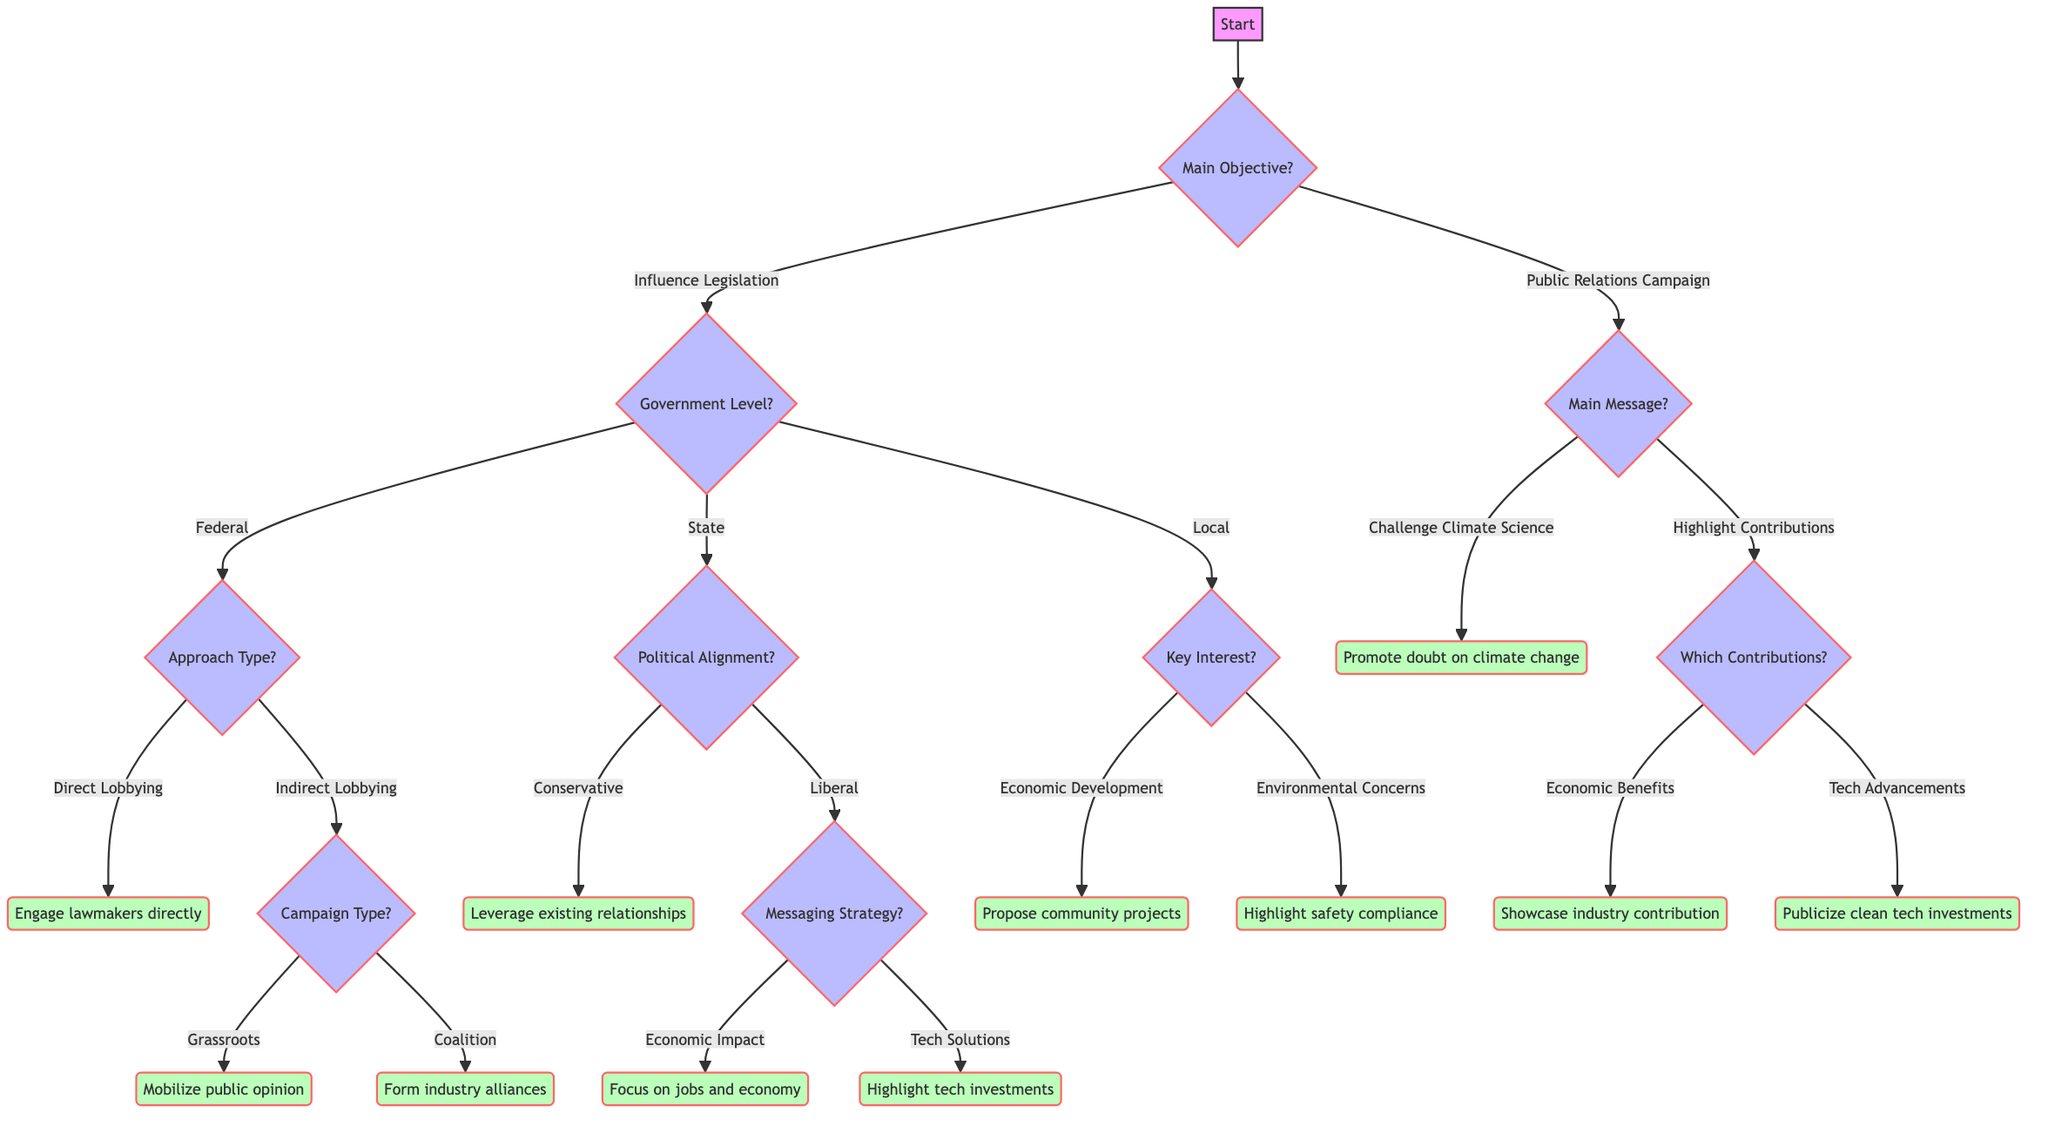What is the main objective of the lobbying effort? The diagram's first node asks about the main objective of the lobbying effort; the options are "Influence Legislation" and "Public Relations Campaign". Since it's a direct inquiry, we can answer by simply choosing one of these options.
Answer: Influence Legislation How many approaches are available under Federal lobbying? From the diagram, if we follow the path starting from "Influence Legislation" and then to "Federal", we see that there are two approaches under Federal: "Direct Lobbying" and "Indirect Lobbying". The count of these options gives us the answer.
Answer: 2 What outcome results from "Grassroots Campaign"? Following the path for "Indirect Lobbying" under "Federal", we further go to "Grassroots Campaign". The outcome specified for this option is "Mobilize public opinion to influence lawmakers." Hence, we can state the corresponding outcome.
Answer: Mobilize public opinion Which type of political alignment leads to leveraging existing relationships? In the section for "State" under "Influence Legislation", the "Conservative" political alignment points toward leveraging existing relationships. We identify this unique connection, indicating what the alignment results in.
Answer: Conservative What is the key interest that leads to proposing community development projects? When tracing the path for "Local" in the diagram, we assess the options and discover that "Economic Development" leads to the outcome of proposing community development projects. Thus, we can directly identify this relationship from the diagram.
Answer: Economic Development What is the messaging strategy when targeting liberal states? Under the "Liberal" political alignment, following the flow leads to the question of the messaging strategy, which has two options: "Economic Impact" and "Technological Solutions". Each will influence the approach taken. This clearly identifies the flow of reasoning in the diagram.
Answer: Messaging Strategy How many outcomes follow from the "Highlighting Positive Contributions" message? From the "Public Relations Campaign" section and leading through to "Highlighting Positive Contributions", we find that this branch breaks into two outcomes: "Economic Benefits" and "Technological Advancements". Therefore, we count these outcomes directly linked to the message.
Answer: 2 What is the outcome if "Challenge Climate Science" is chosen? When we select "Challenge Climate Science" from the "Main Message" in the "Public Relations Campaign" section, the direct outcome specified in the diagram is "Promote material casting doubt on climate change to sway public opinion." We can thus extract the exact phrasing from the diagram.
Answer: Promote material casting doubt on climate change 